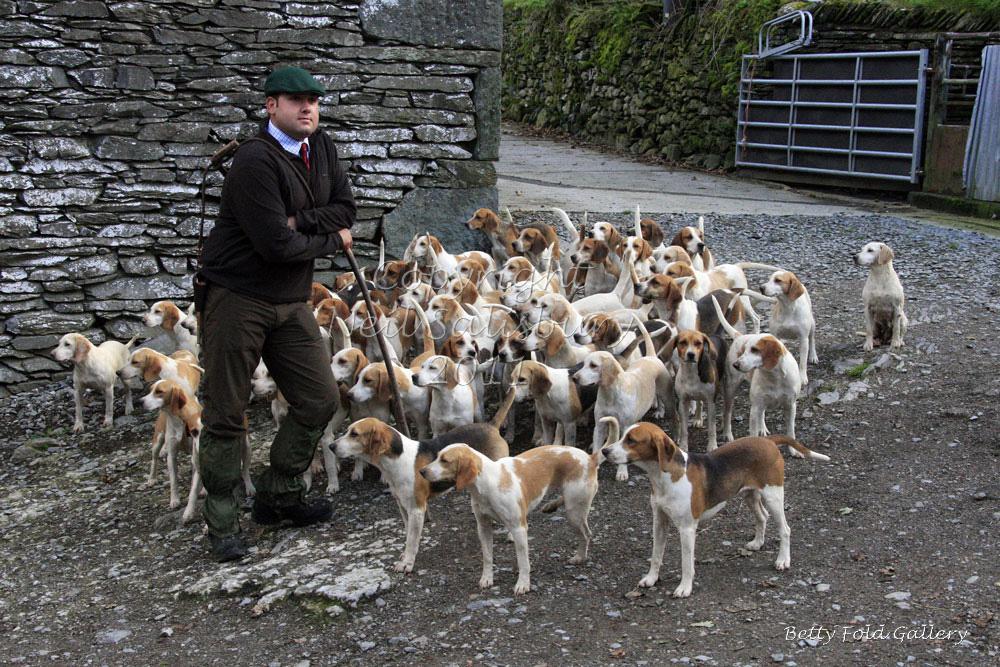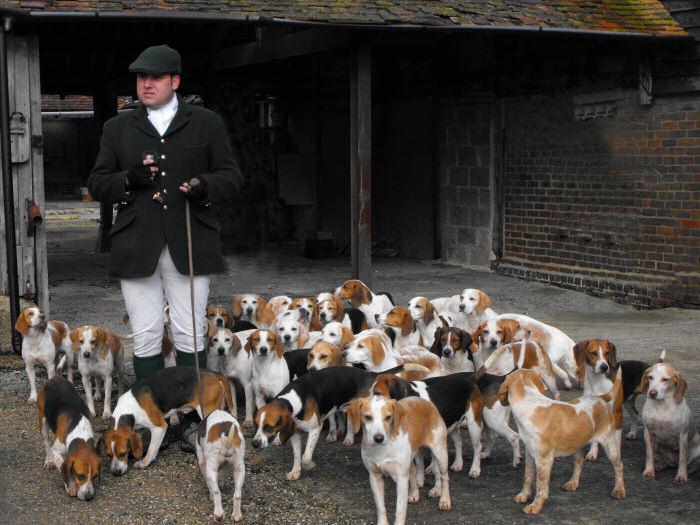The first image is the image on the left, the second image is the image on the right. For the images shown, is this caption "All images contain at least one man in a hat." true? Answer yes or no. Yes. The first image is the image on the left, the second image is the image on the right. Considering the images on both sides, is "There is a man wearing green and blue socks." valid? Answer yes or no. No. 